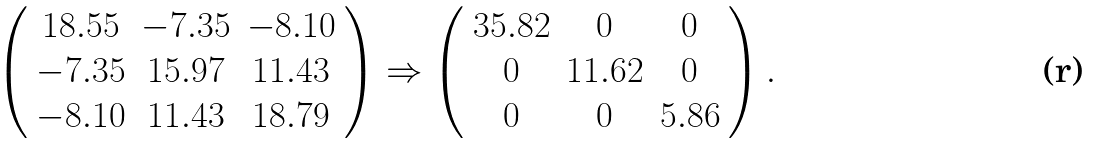<formula> <loc_0><loc_0><loc_500><loc_500>\left ( \begin{array} { c c c } 1 8 . 5 5 & { - } 7 . 3 5 & { - } 8 . 1 0 \\ { - } 7 . 3 5 & 1 5 . 9 7 & 1 1 . 4 3 \\ { - } 8 . 1 0 & 1 1 . 4 3 & 1 8 . 7 9 \\ \end{array} \right ) \Rightarrow \left ( \begin{array} { c c c } 3 5 . 8 2 & 0 & 0 \\ 0 & 1 1 . 6 2 & 0 \\ 0 & 0 & 5 . 8 6 \\ \end{array} \right ) .</formula> 